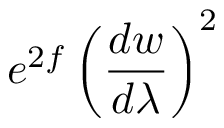Convert formula to latex. <formula><loc_0><loc_0><loc_500><loc_500>e ^ { 2 f } \left ( \frac { d w } { d \lambda } \right ) ^ { 2 }</formula> 